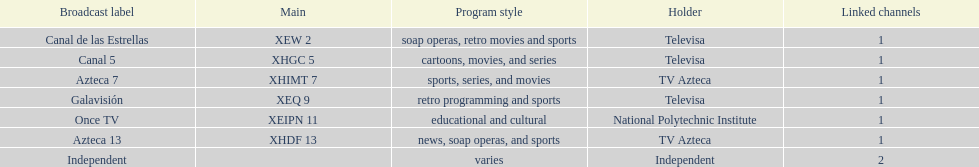What is the only network owned by national polytechnic institute? Once TV. 